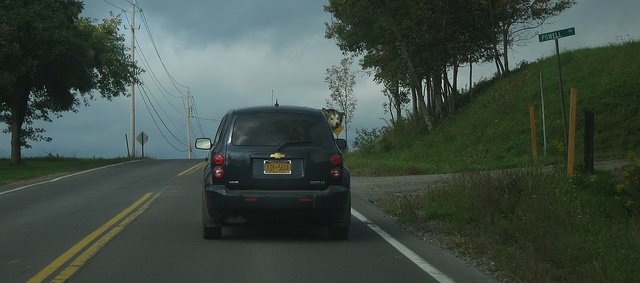Describe the objects in this image and their specific colors. I can see car in black, purple, gray, and darkblue tones and dog in black, gray, and darkgreen tones in this image. 